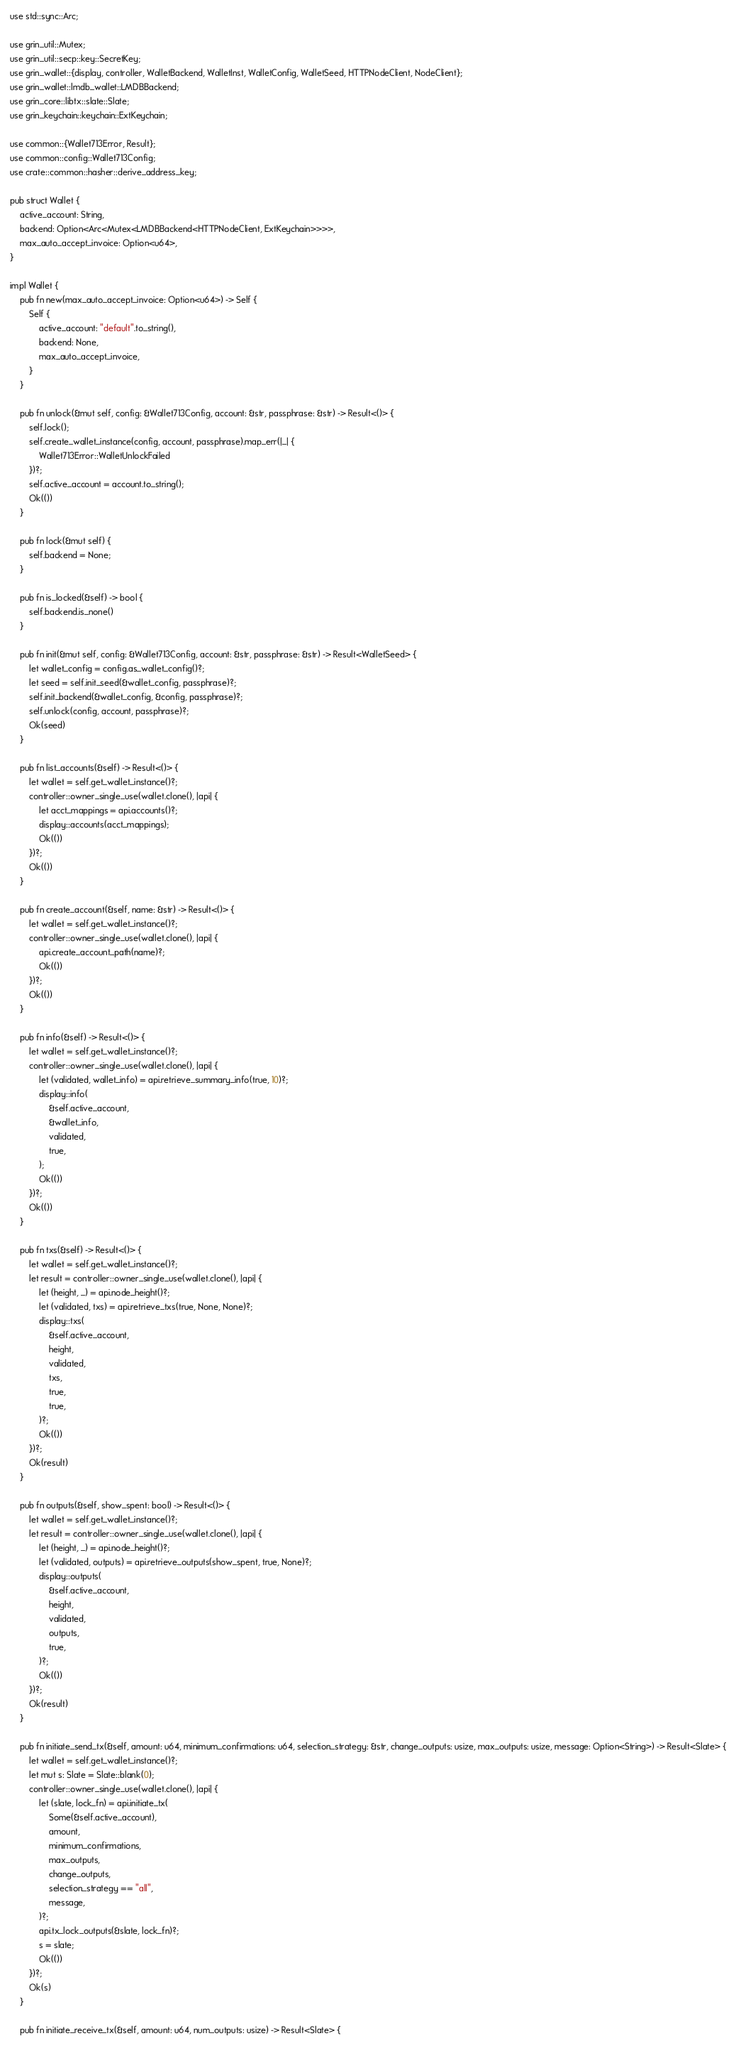<code> <loc_0><loc_0><loc_500><loc_500><_Rust_>use std::sync::Arc;

use grin_util::Mutex;
use grin_util::secp::key::SecretKey;
use grin_wallet::{display, controller, WalletBackend, WalletInst, WalletConfig, WalletSeed, HTTPNodeClient, NodeClient};
use grin_wallet::lmdb_wallet::LMDBBackend;
use grin_core::libtx::slate::Slate;
use grin_keychain::keychain::ExtKeychain;

use common::{Wallet713Error, Result};
use common::config::Wallet713Config;
use crate::common::hasher::derive_address_key;

pub struct Wallet {
    active_account: String,
    backend: Option<Arc<Mutex<LMDBBackend<HTTPNodeClient, ExtKeychain>>>>,
    max_auto_accept_invoice: Option<u64>,
}

impl Wallet {
    pub fn new(max_auto_accept_invoice: Option<u64>) -> Self {
        Self {
            active_account: "default".to_string(),
            backend: None,
            max_auto_accept_invoice,
        }
    }

    pub fn unlock(&mut self, config: &Wallet713Config, account: &str, passphrase: &str) -> Result<()> {
        self.lock();
        self.create_wallet_instance(config, account, passphrase).map_err(|_| {
            Wallet713Error::WalletUnlockFailed
        })?;
        self.active_account = account.to_string();
        Ok(())
    }

    pub fn lock(&mut self) {
        self.backend = None;
    }

    pub fn is_locked(&self) -> bool {
        self.backend.is_none()
    }

    pub fn init(&mut self, config: &Wallet713Config, account: &str, passphrase: &str) -> Result<WalletSeed> {
        let wallet_config = config.as_wallet_config()?;
        let seed = self.init_seed(&wallet_config, passphrase)?;
        self.init_backend(&wallet_config, &config, passphrase)?;
        self.unlock(config, account, passphrase)?;
        Ok(seed)
    }

    pub fn list_accounts(&self) -> Result<()> {
        let wallet = self.get_wallet_instance()?;
        controller::owner_single_use(wallet.clone(), |api| {
            let acct_mappings = api.accounts()?;
            display::accounts(acct_mappings);
            Ok(())
        })?;
        Ok(())
    }

    pub fn create_account(&self, name: &str) -> Result<()> {
        let wallet = self.get_wallet_instance()?;
        controller::owner_single_use(wallet.clone(), |api| {
            api.create_account_path(name)?;
            Ok(())
        })?;
        Ok(())
    }

    pub fn info(&self) -> Result<()> {
        let wallet = self.get_wallet_instance()?;
        controller::owner_single_use(wallet.clone(), |api| {
            let (validated, wallet_info) = api.retrieve_summary_info(true, 10)?;
            display::info(
                &self.active_account,
                &wallet_info,
                validated,
                true,
            );
            Ok(())
        })?;
        Ok(())
    }

    pub fn txs(&self) -> Result<()> {
        let wallet = self.get_wallet_instance()?;
        let result = controller::owner_single_use(wallet.clone(), |api| {
            let (height, _) = api.node_height()?;
            let (validated, txs) = api.retrieve_txs(true, None, None)?;
            display::txs(
                &self.active_account,
                height,
                validated,
                txs,
                true,
                true,
            )?;
            Ok(())
        })?;
        Ok(result)
    }

    pub fn outputs(&self, show_spent: bool) -> Result<()> {
        let wallet = self.get_wallet_instance()?;
        let result = controller::owner_single_use(wallet.clone(), |api| {
            let (height, _) = api.node_height()?;
            let (validated, outputs) = api.retrieve_outputs(show_spent, true, None)?;
            display::outputs(
                &self.active_account,
                height,
                validated,
                outputs,
                true,
            )?;
            Ok(())
        })?;
        Ok(result)
    }

    pub fn initiate_send_tx(&self, amount: u64, minimum_confirmations: u64, selection_strategy: &str, change_outputs: usize, max_outputs: usize, message: Option<String>) -> Result<Slate> {
        let wallet = self.get_wallet_instance()?;
        let mut s: Slate = Slate::blank(0);
        controller::owner_single_use(wallet.clone(), |api| {
            let (slate, lock_fn) = api.initiate_tx(
                Some(&self.active_account),
                amount,
                minimum_confirmations,
                max_outputs,
                change_outputs,
                selection_strategy == "all",
                message,
            )?;
            api.tx_lock_outputs(&slate, lock_fn)?;
            s = slate;
            Ok(())
        })?;
        Ok(s)
    }

    pub fn initiate_receive_tx(&self, amount: u64, num_outputs: usize) -> Result<Slate> {</code> 